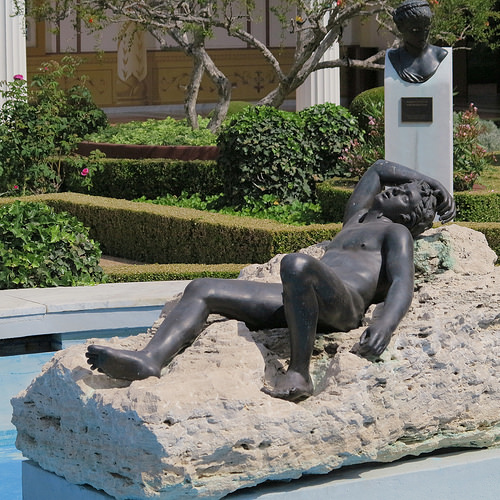<image>
Is there a statue next to the plant? Yes. The statue is positioned adjacent to the plant, located nearby in the same general area. Is there a bush behind the sculpture? Yes. From this viewpoint, the bush is positioned behind the sculpture, with the sculpture partially or fully occluding the bush. 